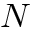<formula> <loc_0><loc_0><loc_500><loc_500>N</formula> 